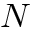<formula> <loc_0><loc_0><loc_500><loc_500>N</formula> 